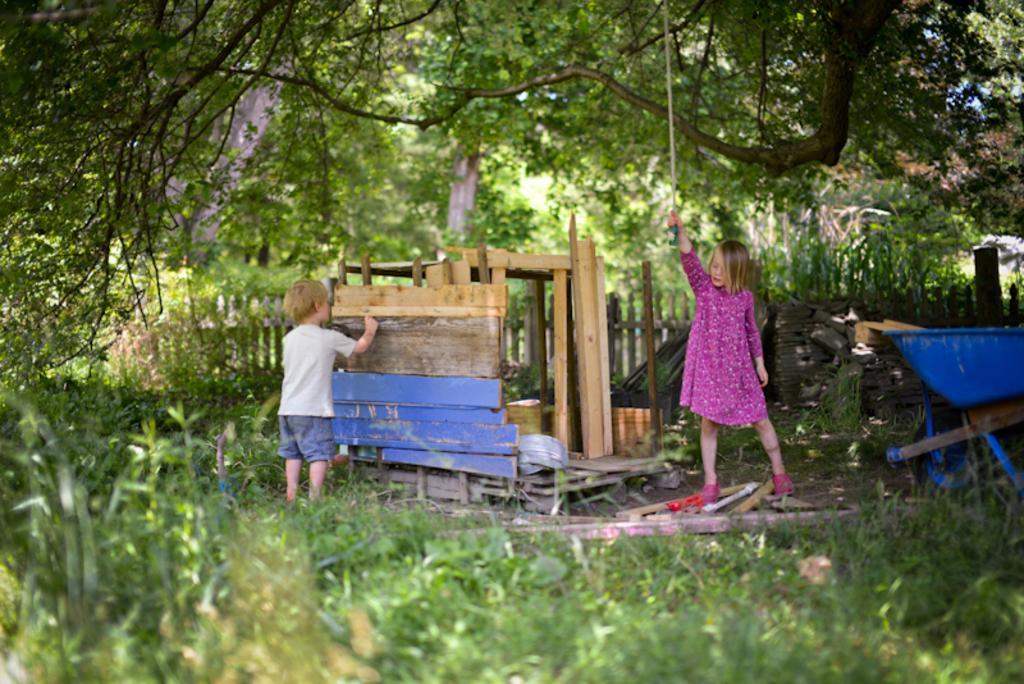In one or two sentences, can you explain what this image depicts? In this picture we can see plants, cart, boy, wooden objects, fence, girl holding an object with her hand and some objects and in the background we can see trees. 